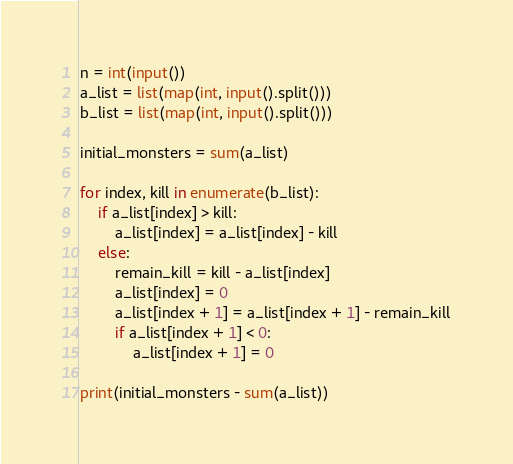Convert code to text. <code><loc_0><loc_0><loc_500><loc_500><_Python_>n = int(input())
a_list = list(map(int, input().split()))
b_list = list(map(int, input().split()))

initial_monsters = sum(a_list)

for index, kill in enumerate(b_list):
    if a_list[index] > kill:
        a_list[index] = a_list[index] - kill
    else:
        remain_kill = kill - a_list[index]
        a_list[index] = 0
        a_list[index + 1] = a_list[index + 1] - remain_kill
        if a_list[index + 1] < 0:
            a_list[index + 1] = 0

print(initial_monsters - sum(a_list))</code> 